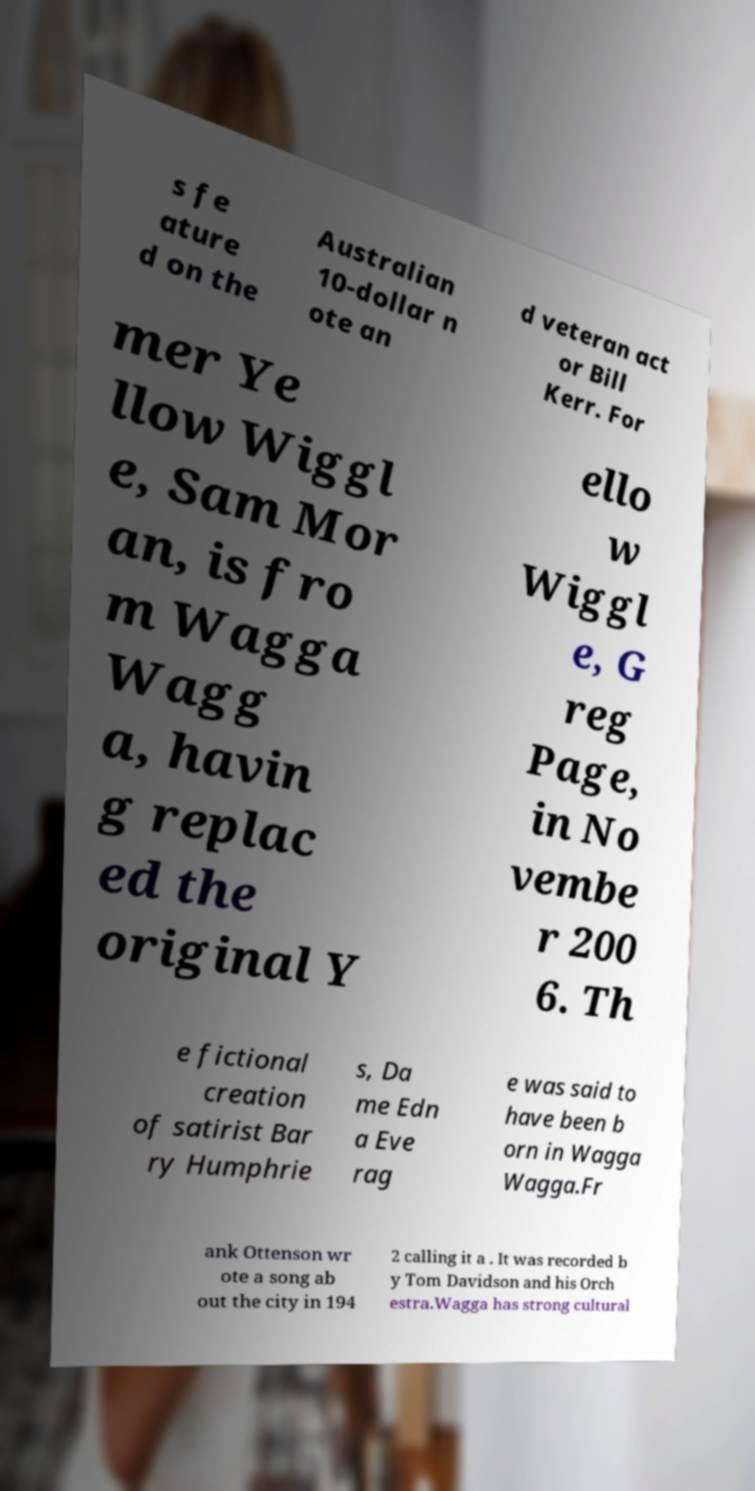Please identify and transcribe the text found in this image. s fe ature d on the Australian 10-dollar n ote an d veteran act or Bill Kerr. For mer Ye llow Wiggl e, Sam Mor an, is fro m Wagga Wagg a, havin g replac ed the original Y ello w Wiggl e, G reg Page, in No vembe r 200 6. Th e fictional creation of satirist Bar ry Humphrie s, Da me Edn a Eve rag e was said to have been b orn in Wagga Wagga.Fr ank Ottenson wr ote a song ab out the city in 194 2 calling it a . It was recorded b y Tom Davidson and his Orch estra.Wagga has strong cultural 